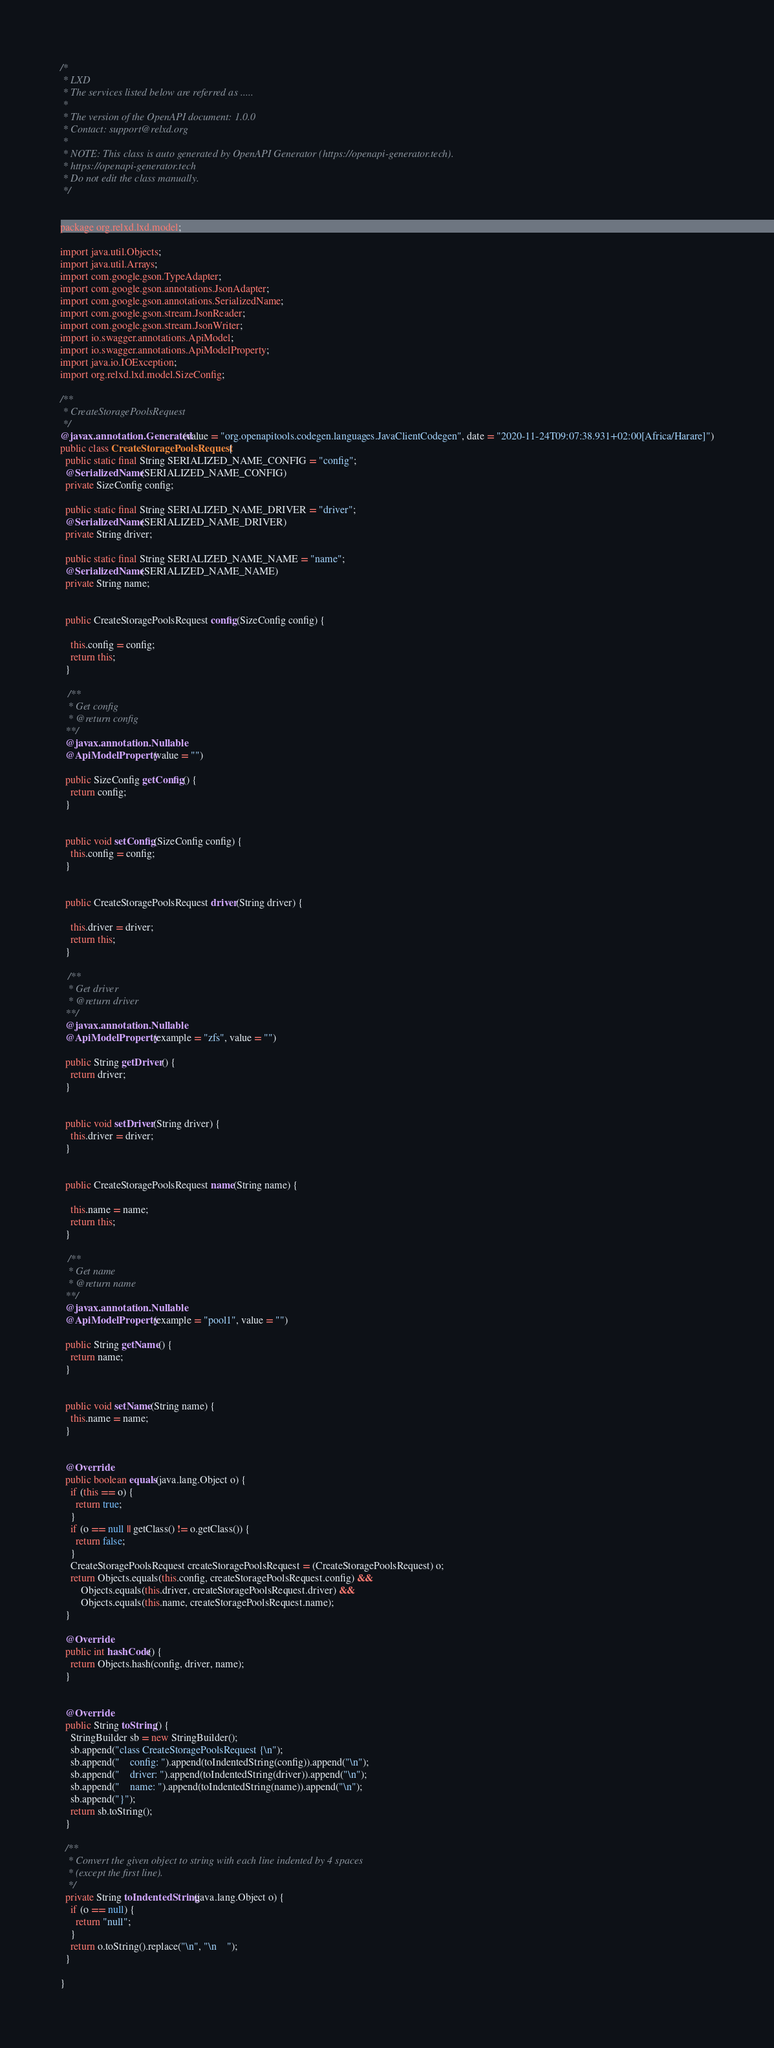Convert code to text. <code><loc_0><loc_0><loc_500><loc_500><_Java_>/*
 * LXD
 * The services listed below are referred as .....
 *
 * The version of the OpenAPI document: 1.0.0
 * Contact: support@relxd.org
 *
 * NOTE: This class is auto generated by OpenAPI Generator (https://openapi-generator.tech).
 * https://openapi-generator.tech
 * Do not edit the class manually.
 */


package org.relxd.lxd.model;

import java.util.Objects;
import java.util.Arrays;
import com.google.gson.TypeAdapter;
import com.google.gson.annotations.JsonAdapter;
import com.google.gson.annotations.SerializedName;
import com.google.gson.stream.JsonReader;
import com.google.gson.stream.JsonWriter;
import io.swagger.annotations.ApiModel;
import io.swagger.annotations.ApiModelProperty;
import java.io.IOException;
import org.relxd.lxd.model.SizeConfig;

/**
 * CreateStoragePoolsRequest
 */
@javax.annotation.Generated(value = "org.openapitools.codegen.languages.JavaClientCodegen", date = "2020-11-24T09:07:38.931+02:00[Africa/Harare]")
public class CreateStoragePoolsRequest {
  public static final String SERIALIZED_NAME_CONFIG = "config";
  @SerializedName(SERIALIZED_NAME_CONFIG)
  private SizeConfig config;

  public static final String SERIALIZED_NAME_DRIVER = "driver";
  @SerializedName(SERIALIZED_NAME_DRIVER)
  private String driver;

  public static final String SERIALIZED_NAME_NAME = "name";
  @SerializedName(SERIALIZED_NAME_NAME)
  private String name;


  public CreateStoragePoolsRequest config(SizeConfig config) {
    
    this.config = config;
    return this;
  }

   /**
   * Get config
   * @return config
  **/
  @javax.annotation.Nullable
  @ApiModelProperty(value = "")

  public SizeConfig getConfig() {
    return config;
  }


  public void setConfig(SizeConfig config) {
    this.config = config;
  }


  public CreateStoragePoolsRequest driver(String driver) {
    
    this.driver = driver;
    return this;
  }

   /**
   * Get driver
   * @return driver
  **/
  @javax.annotation.Nullable
  @ApiModelProperty(example = "zfs", value = "")

  public String getDriver() {
    return driver;
  }


  public void setDriver(String driver) {
    this.driver = driver;
  }


  public CreateStoragePoolsRequest name(String name) {
    
    this.name = name;
    return this;
  }

   /**
   * Get name
   * @return name
  **/
  @javax.annotation.Nullable
  @ApiModelProperty(example = "pool1", value = "")

  public String getName() {
    return name;
  }


  public void setName(String name) {
    this.name = name;
  }


  @Override
  public boolean equals(java.lang.Object o) {
    if (this == o) {
      return true;
    }
    if (o == null || getClass() != o.getClass()) {
      return false;
    }
    CreateStoragePoolsRequest createStoragePoolsRequest = (CreateStoragePoolsRequest) o;
    return Objects.equals(this.config, createStoragePoolsRequest.config) &&
        Objects.equals(this.driver, createStoragePoolsRequest.driver) &&
        Objects.equals(this.name, createStoragePoolsRequest.name);
  }

  @Override
  public int hashCode() {
    return Objects.hash(config, driver, name);
  }


  @Override
  public String toString() {
    StringBuilder sb = new StringBuilder();
    sb.append("class CreateStoragePoolsRequest {\n");
    sb.append("    config: ").append(toIndentedString(config)).append("\n");
    sb.append("    driver: ").append(toIndentedString(driver)).append("\n");
    sb.append("    name: ").append(toIndentedString(name)).append("\n");
    sb.append("}");
    return sb.toString();
  }

  /**
   * Convert the given object to string with each line indented by 4 spaces
   * (except the first line).
   */
  private String toIndentedString(java.lang.Object o) {
    if (o == null) {
      return "null";
    }
    return o.toString().replace("\n", "\n    ");
  }

}

</code> 